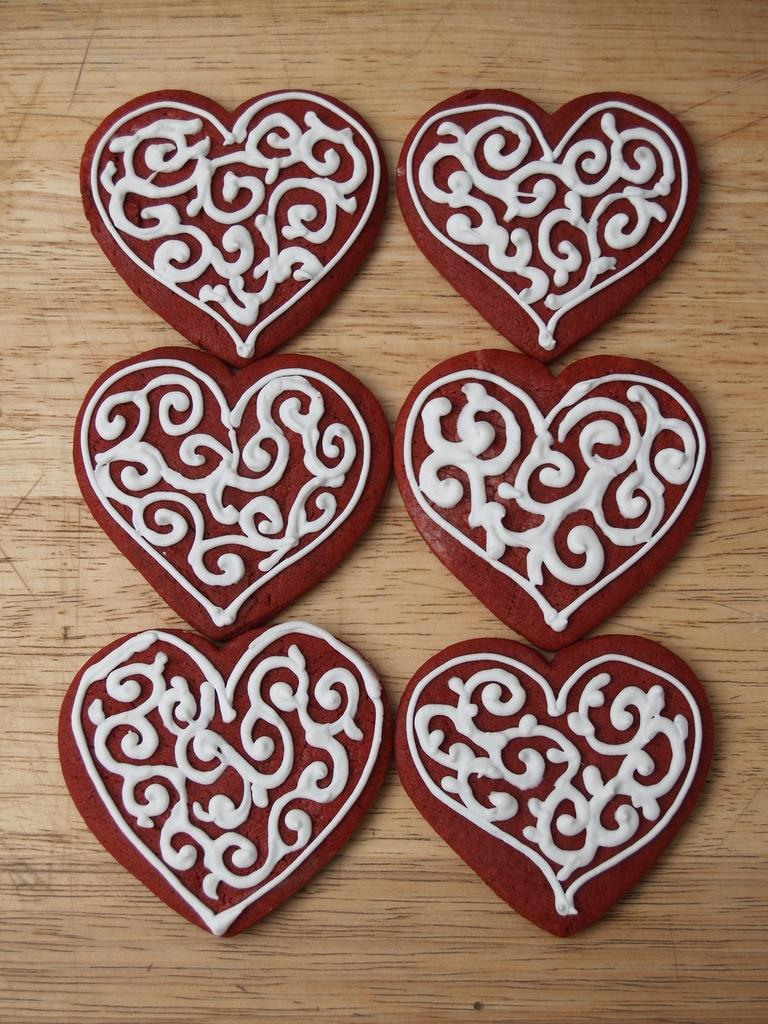What shape are the objects in the image? The objects in the image are heart-shaped. Where are the heart-shaped objects located? The heart-shaped objects are on a table. What type of learning material is visible in the image? There is no learning material present in the image. What type of flag is visible in the image? There is no flag present in the image. Is there a woman in the image? There is no woman present in the image. 